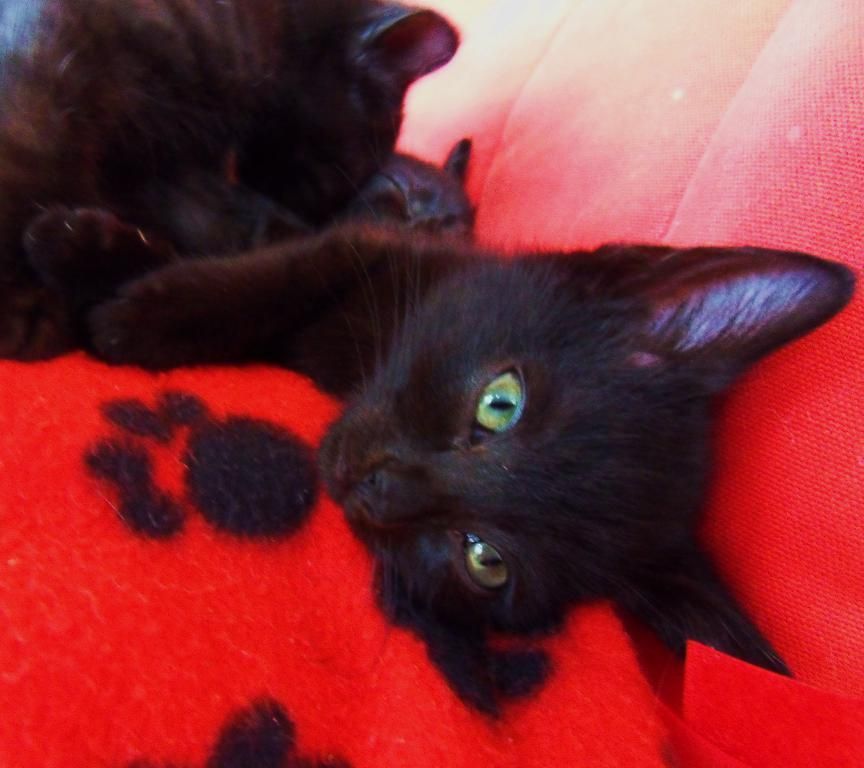What type of animals are in the image? There are cats in the image. What color are the cats? The cats are black in color. What else can be seen in the image besides the cats? There is a red and black cloth visible in the image. What is the purpose of the police sign in the image? There is no police sign present in the image. 